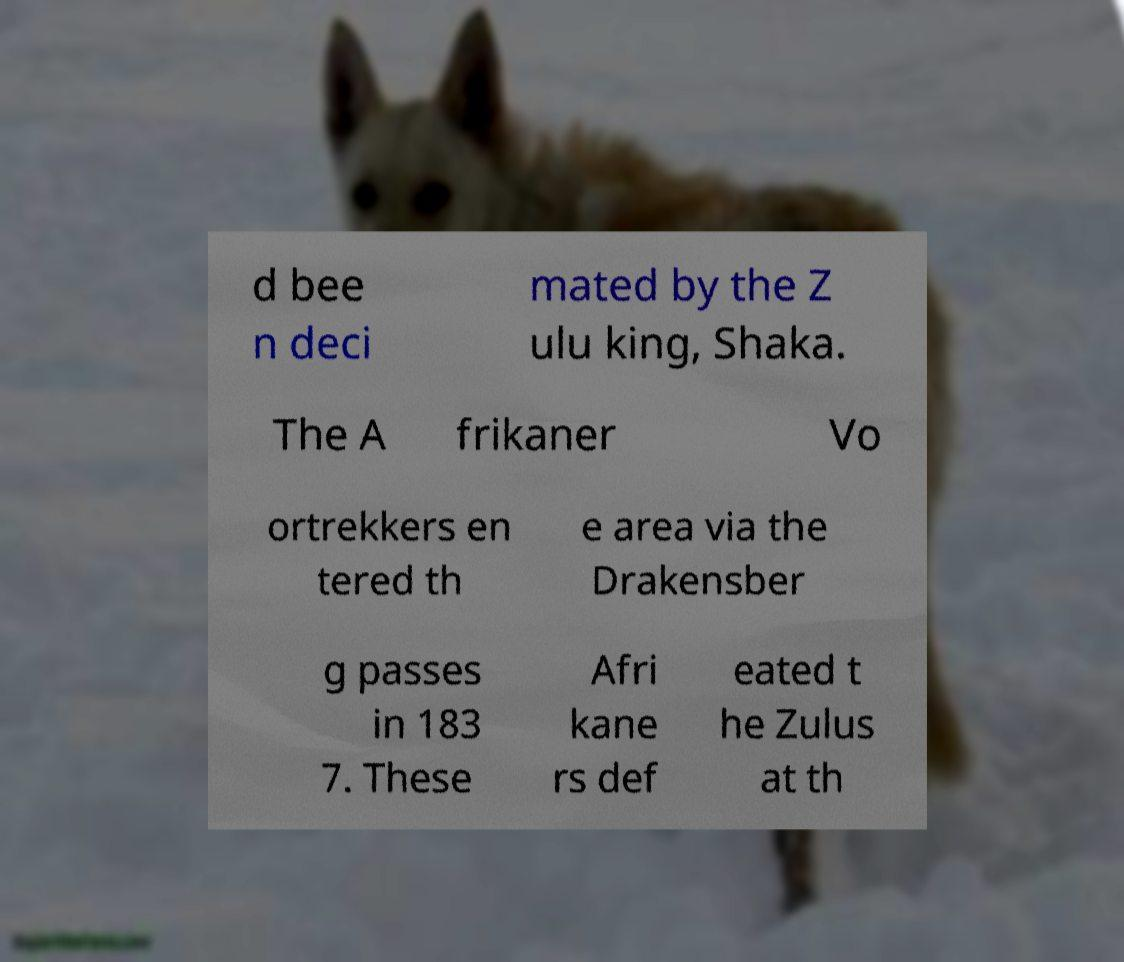Please read and relay the text visible in this image. What does it say? d bee n deci mated by the Z ulu king, Shaka. The A frikaner Vo ortrekkers en tered th e area via the Drakensber g passes in 183 7. These Afri kane rs def eated t he Zulus at th 